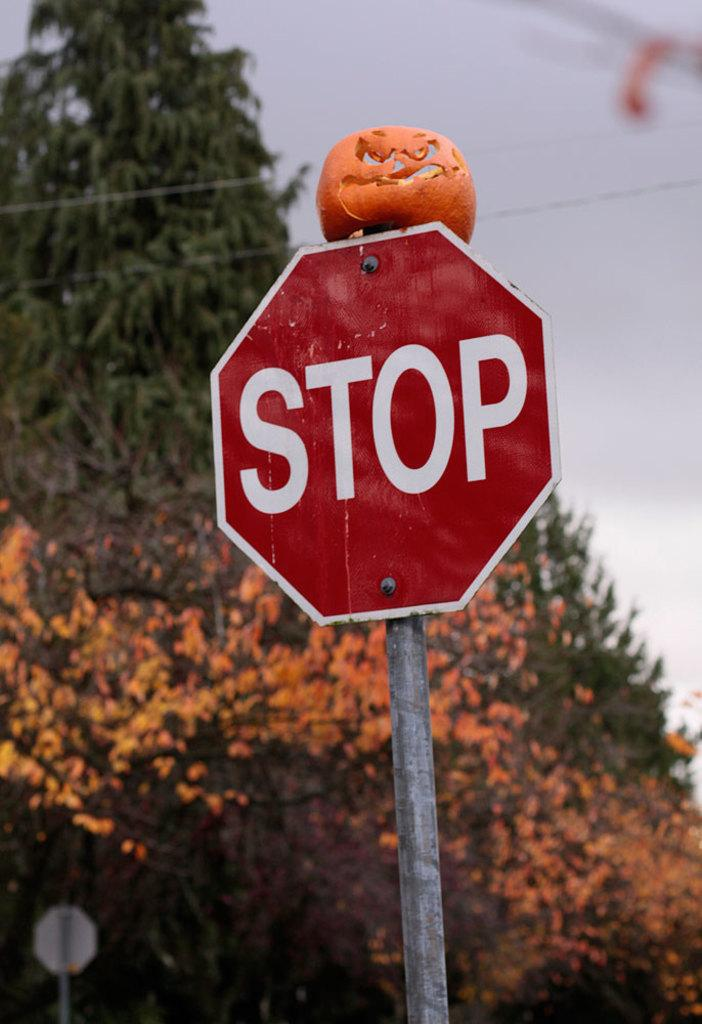<image>
Share a concise interpretation of the image provided. A carved pumpkin is on top of a red sign that says Stop. 